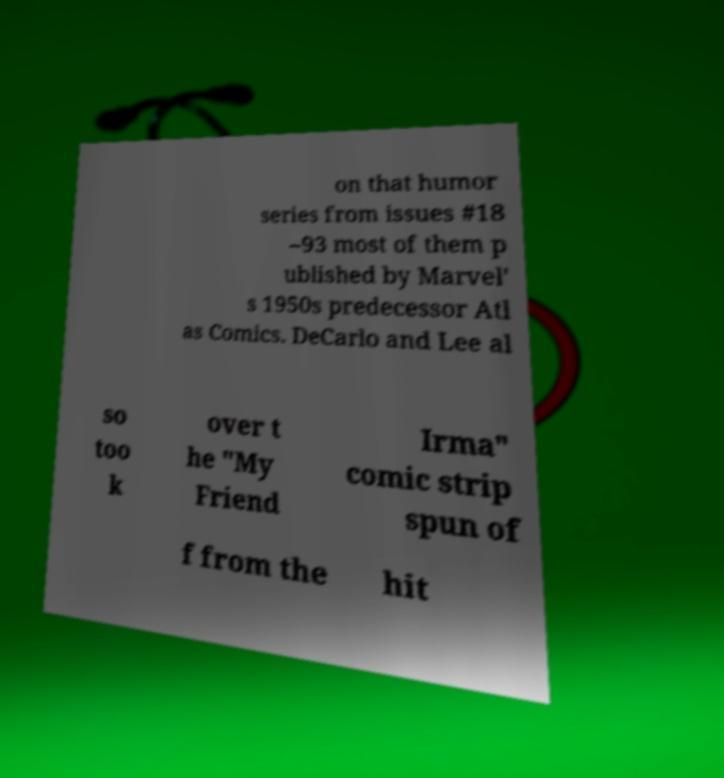There's text embedded in this image that I need extracted. Can you transcribe it verbatim? on that humor series from issues #18 –93 most of them p ublished by Marvel' s 1950s predecessor Atl as Comics. DeCarlo and Lee al so too k over t he "My Friend Irma" comic strip spun of f from the hit 